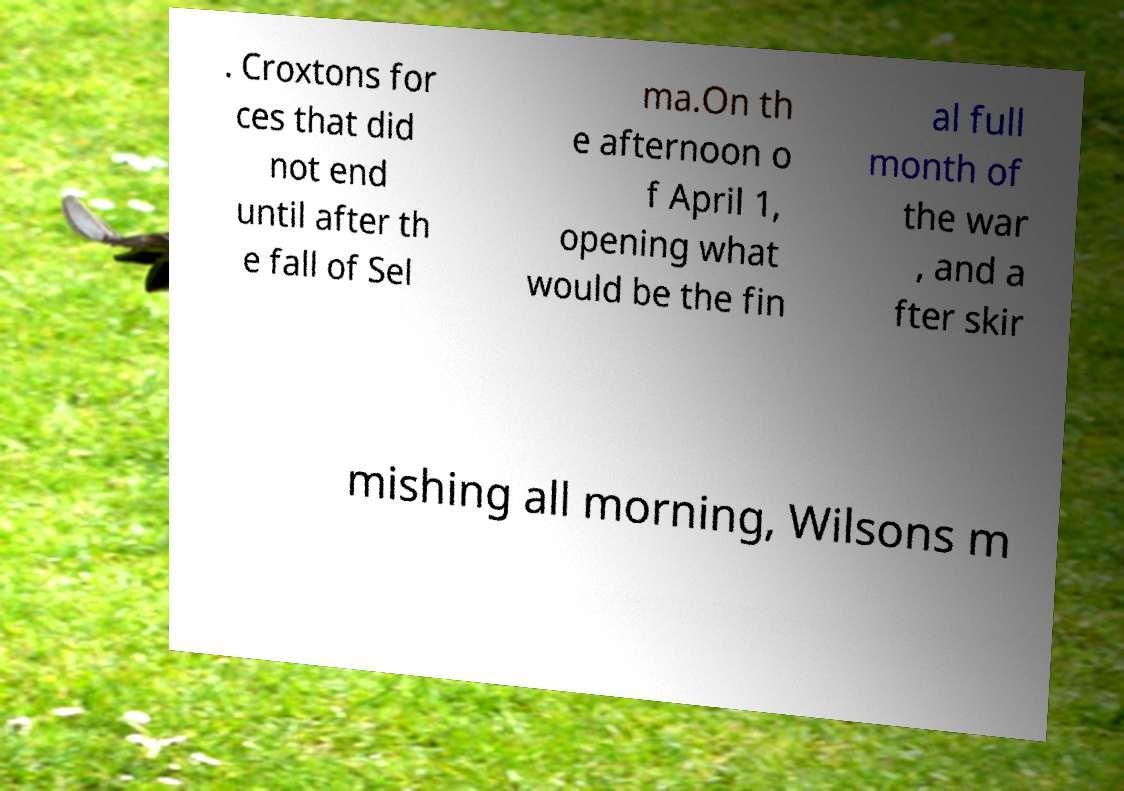Can you accurately transcribe the text from the provided image for me? . Croxtons for ces that did not end until after th e fall of Sel ma.On th e afternoon o f April 1, opening what would be the fin al full month of the war , and a fter skir mishing all morning, Wilsons m 